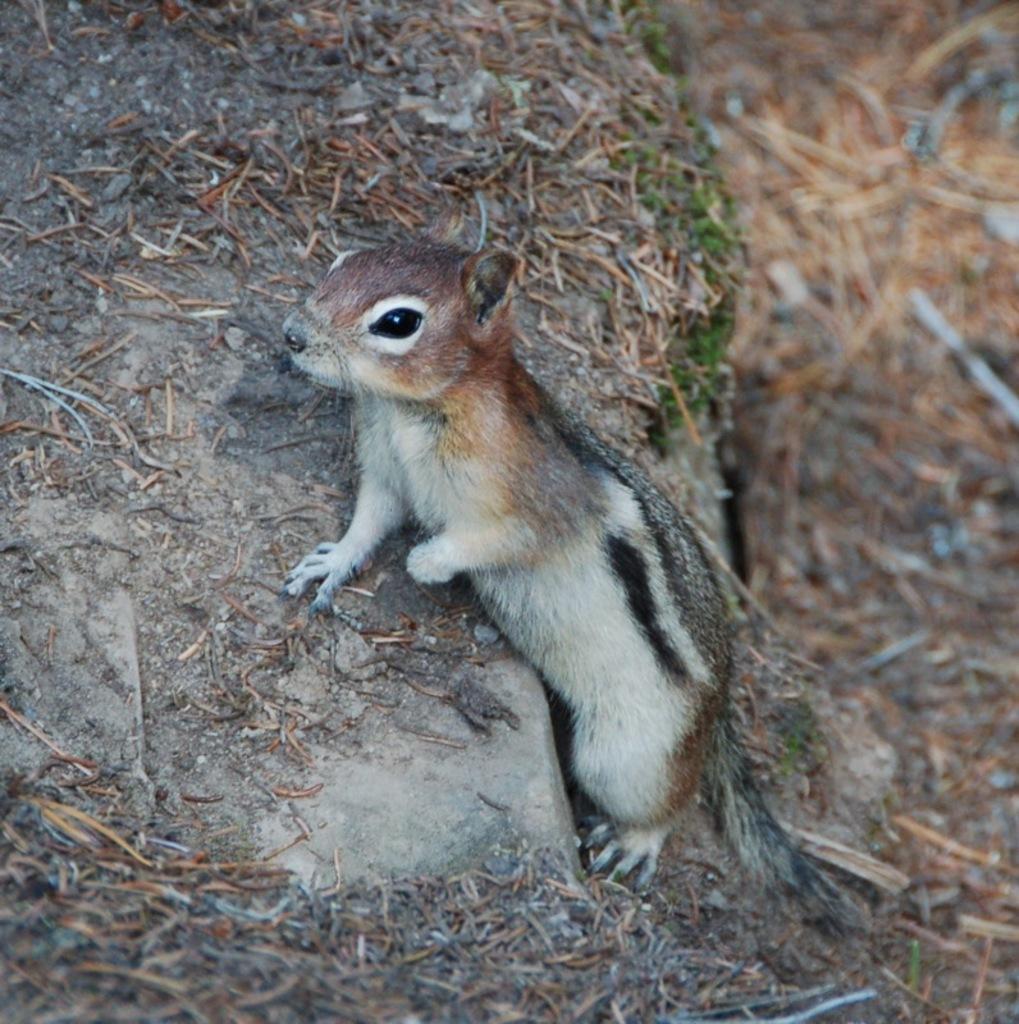In one or two sentences, can you explain what this image depicts? In this image, we can see a squirrel. Here it looks like a stairs. On the right side of the image, we can see a blur view. 